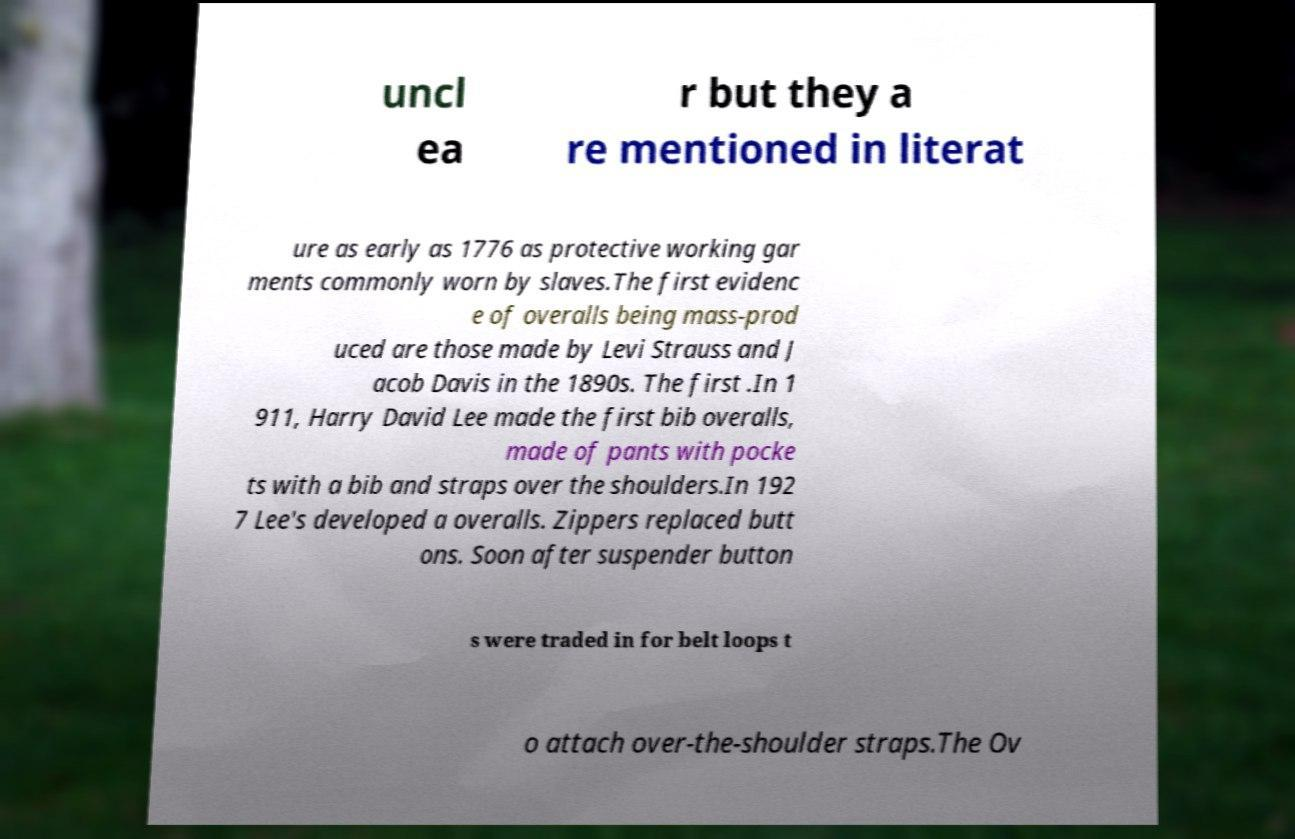What messages or text are displayed in this image? I need them in a readable, typed format. uncl ea r but they a re mentioned in literat ure as early as 1776 as protective working gar ments commonly worn by slaves.The first evidenc e of overalls being mass-prod uced are those made by Levi Strauss and J acob Davis in the 1890s. The first .In 1 911, Harry David Lee made the first bib overalls, made of pants with pocke ts with a bib and straps over the shoulders.In 192 7 Lee's developed a overalls. Zippers replaced butt ons. Soon after suspender button s were traded in for belt loops t o attach over-the-shoulder straps.The Ov 